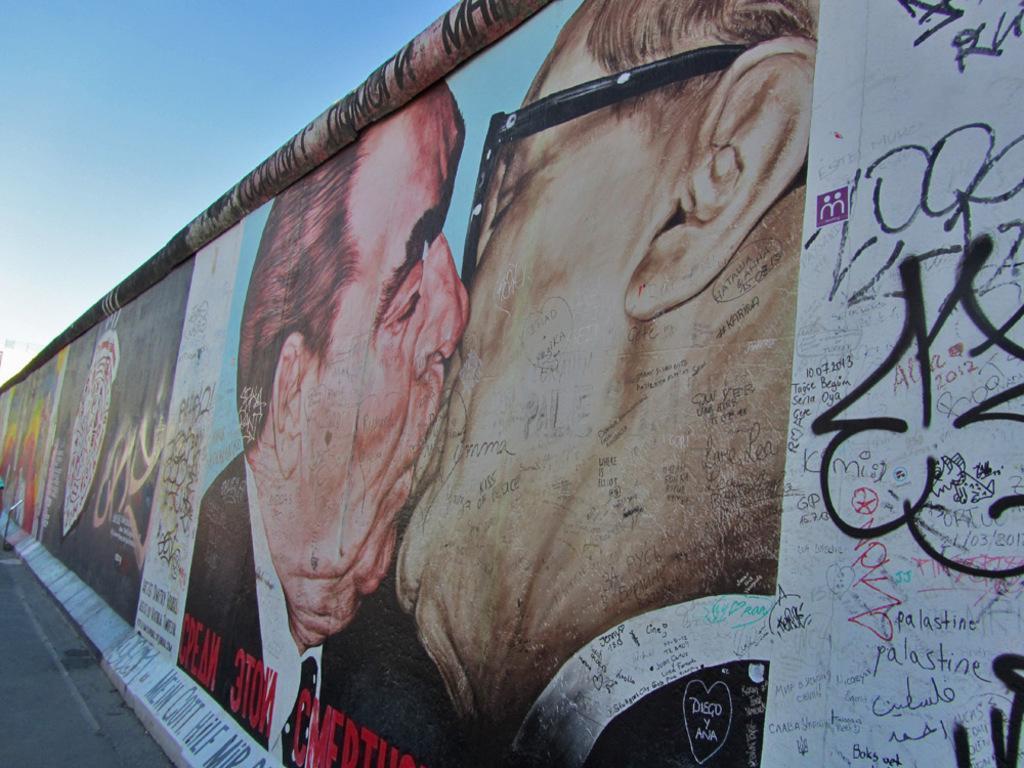Could you give a brief overview of what you see in this image? In this picture we can see a wall, here we can see posters and graffiti, we can see two persons here, there is the sky at the top of the picture. 